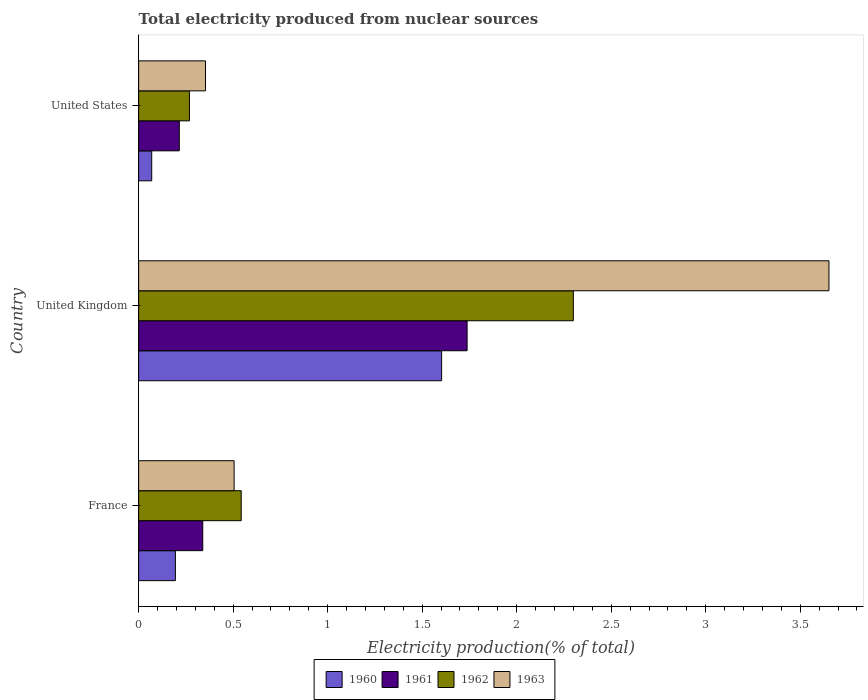How many different coloured bars are there?
Your response must be concise. 4. Are the number of bars per tick equal to the number of legend labels?
Offer a terse response. Yes. How many bars are there on the 1st tick from the bottom?
Give a very brief answer. 4. What is the total electricity produced in 1963 in United States?
Keep it short and to the point. 0.35. Across all countries, what is the maximum total electricity produced in 1963?
Offer a terse response. 3.65. Across all countries, what is the minimum total electricity produced in 1960?
Offer a terse response. 0.07. In which country was the total electricity produced in 1961 minimum?
Your response must be concise. United States. What is the total total electricity produced in 1961 in the graph?
Keep it short and to the point. 2.29. What is the difference between the total electricity produced in 1962 in France and that in United Kingdom?
Give a very brief answer. -1.76. What is the difference between the total electricity produced in 1961 in United States and the total electricity produced in 1963 in United Kingdom?
Give a very brief answer. -3.44. What is the average total electricity produced in 1963 per country?
Provide a short and direct response. 1.5. What is the difference between the total electricity produced in 1963 and total electricity produced in 1960 in France?
Keep it short and to the point. 0.31. In how many countries, is the total electricity produced in 1963 greater than 3.6 %?
Ensure brevity in your answer.  1. What is the ratio of the total electricity produced in 1960 in United Kingdom to that in United States?
Your answer should be compact. 23.14. Is the total electricity produced in 1962 in France less than that in United States?
Provide a short and direct response. No. Is the difference between the total electricity produced in 1963 in United Kingdom and United States greater than the difference between the total electricity produced in 1960 in United Kingdom and United States?
Your response must be concise. Yes. What is the difference between the highest and the second highest total electricity produced in 1961?
Your response must be concise. 1.4. What is the difference between the highest and the lowest total electricity produced in 1963?
Your answer should be very brief. 3.3. Is it the case that in every country, the sum of the total electricity produced in 1962 and total electricity produced in 1960 is greater than the sum of total electricity produced in 1963 and total electricity produced in 1961?
Keep it short and to the point. No. Is it the case that in every country, the sum of the total electricity produced in 1963 and total electricity produced in 1961 is greater than the total electricity produced in 1962?
Offer a terse response. Yes. Are all the bars in the graph horizontal?
Provide a succinct answer. Yes. How many countries are there in the graph?
Your response must be concise. 3. Are the values on the major ticks of X-axis written in scientific E-notation?
Offer a very short reply. No. Does the graph contain any zero values?
Offer a terse response. No. How many legend labels are there?
Make the answer very short. 4. What is the title of the graph?
Provide a succinct answer. Total electricity produced from nuclear sources. Does "1982" appear as one of the legend labels in the graph?
Provide a succinct answer. No. What is the Electricity production(% of total) in 1960 in France?
Your response must be concise. 0.19. What is the Electricity production(% of total) in 1961 in France?
Make the answer very short. 0.34. What is the Electricity production(% of total) of 1962 in France?
Your answer should be compact. 0.54. What is the Electricity production(% of total) in 1963 in France?
Ensure brevity in your answer.  0.51. What is the Electricity production(% of total) of 1960 in United Kingdom?
Keep it short and to the point. 1.6. What is the Electricity production(% of total) in 1961 in United Kingdom?
Your answer should be compact. 1.74. What is the Electricity production(% of total) of 1962 in United Kingdom?
Give a very brief answer. 2.3. What is the Electricity production(% of total) of 1963 in United Kingdom?
Your answer should be compact. 3.65. What is the Electricity production(% of total) in 1960 in United States?
Provide a short and direct response. 0.07. What is the Electricity production(% of total) of 1961 in United States?
Provide a short and direct response. 0.22. What is the Electricity production(% of total) of 1962 in United States?
Provide a succinct answer. 0.27. What is the Electricity production(% of total) of 1963 in United States?
Offer a terse response. 0.35. Across all countries, what is the maximum Electricity production(% of total) in 1960?
Your answer should be very brief. 1.6. Across all countries, what is the maximum Electricity production(% of total) in 1961?
Keep it short and to the point. 1.74. Across all countries, what is the maximum Electricity production(% of total) of 1962?
Your response must be concise. 2.3. Across all countries, what is the maximum Electricity production(% of total) of 1963?
Offer a very short reply. 3.65. Across all countries, what is the minimum Electricity production(% of total) in 1960?
Give a very brief answer. 0.07. Across all countries, what is the minimum Electricity production(% of total) of 1961?
Your answer should be very brief. 0.22. Across all countries, what is the minimum Electricity production(% of total) in 1962?
Make the answer very short. 0.27. Across all countries, what is the minimum Electricity production(% of total) of 1963?
Keep it short and to the point. 0.35. What is the total Electricity production(% of total) of 1960 in the graph?
Keep it short and to the point. 1.87. What is the total Electricity production(% of total) of 1961 in the graph?
Offer a very short reply. 2.29. What is the total Electricity production(% of total) in 1962 in the graph?
Offer a very short reply. 3.11. What is the total Electricity production(% of total) in 1963 in the graph?
Make the answer very short. 4.51. What is the difference between the Electricity production(% of total) in 1960 in France and that in United Kingdom?
Give a very brief answer. -1.41. What is the difference between the Electricity production(% of total) in 1961 in France and that in United Kingdom?
Provide a short and direct response. -1.4. What is the difference between the Electricity production(% of total) of 1962 in France and that in United Kingdom?
Ensure brevity in your answer.  -1.76. What is the difference between the Electricity production(% of total) of 1963 in France and that in United Kingdom?
Offer a terse response. -3.15. What is the difference between the Electricity production(% of total) in 1960 in France and that in United States?
Your answer should be compact. 0.13. What is the difference between the Electricity production(% of total) in 1961 in France and that in United States?
Provide a succinct answer. 0.12. What is the difference between the Electricity production(% of total) in 1962 in France and that in United States?
Provide a short and direct response. 0.27. What is the difference between the Electricity production(% of total) in 1963 in France and that in United States?
Your response must be concise. 0.15. What is the difference between the Electricity production(% of total) in 1960 in United Kingdom and that in United States?
Offer a very short reply. 1.53. What is the difference between the Electricity production(% of total) of 1961 in United Kingdom and that in United States?
Give a very brief answer. 1.52. What is the difference between the Electricity production(% of total) of 1962 in United Kingdom and that in United States?
Offer a terse response. 2.03. What is the difference between the Electricity production(% of total) in 1963 in United Kingdom and that in United States?
Offer a terse response. 3.3. What is the difference between the Electricity production(% of total) of 1960 in France and the Electricity production(% of total) of 1961 in United Kingdom?
Provide a short and direct response. -1.54. What is the difference between the Electricity production(% of total) of 1960 in France and the Electricity production(% of total) of 1962 in United Kingdom?
Your answer should be very brief. -2.11. What is the difference between the Electricity production(% of total) of 1960 in France and the Electricity production(% of total) of 1963 in United Kingdom?
Keep it short and to the point. -3.46. What is the difference between the Electricity production(% of total) in 1961 in France and the Electricity production(% of total) in 1962 in United Kingdom?
Keep it short and to the point. -1.96. What is the difference between the Electricity production(% of total) of 1961 in France and the Electricity production(% of total) of 1963 in United Kingdom?
Ensure brevity in your answer.  -3.31. What is the difference between the Electricity production(% of total) of 1962 in France and the Electricity production(% of total) of 1963 in United Kingdom?
Provide a short and direct response. -3.11. What is the difference between the Electricity production(% of total) in 1960 in France and the Electricity production(% of total) in 1961 in United States?
Keep it short and to the point. -0.02. What is the difference between the Electricity production(% of total) of 1960 in France and the Electricity production(% of total) of 1962 in United States?
Provide a succinct answer. -0.07. What is the difference between the Electricity production(% of total) in 1960 in France and the Electricity production(% of total) in 1963 in United States?
Offer a terse response. -0.16. What is the difference between the Electricity production(% of total) in 1961 in France and the Electricity production(% of total) in 1962 in United States?
Keep it short and to the point. 0.07. What is the difference between the Electricity production(% of total) of 1961 in France and the Electricity production(% of total) of 1963 in United States?
Offer a very short reply. -0.01. What is the difference between the Electricity production(% of total) of 1962 in France and the Electricity production(% of total) of 1963 in United States?
Keep it short and to the point. 0.19. What is the difference between the Electricity production(% of total) in 1960 in United Kingdom and the Electricity production(% of total) in 1961 in United States?
Offer a terse response. 1.39. What is the difference between the Electricity production(% of total) in 1960 in United Kingdom and the Electricity production(% of total) in 1962 in United States?
Give a very brief answer. 1.33. What is the difference between the Electricity production(% of total) of 1960 in United Kingdom and the Electricity production(% of total) of 1963 in United States?
Ensure brevity in your answer.  1.25. What is the difference between the Electricity production(% of total) in 1961 in United Kingdom and the Electricity production(% of total) in 1962 in United States?
Ensure brevity in your answer.  1.47. What is the difference between the Electricity production(% of total) of 1961 in United Kingdom and the Electricity production(% of total) of 1963 in United States?
Your answer should be compact. 1.38. What is the difference between the Electricity production(% of total) in 1962 in United Kingdom and the Electricity production(% of total) in 1963 in United States?
Provide a short and direct response. 1.95. What is the average Electricity production(% of total) of 1960 per country?
Provide a succinct answer. 0.62. What is the average Electricity production(% of total) of 1961 per country?
Offer a very short reply. 0.76. What is the average Electricity production(% of total) of 1962 per country?
Provide a short and direct response. 1.04. What is the average Electricity production(% of total) in 1963 per country?
Give a very brief answer. 1.5. What is the difference between the Electricity production(% of total) in 1960 and Electricity production(% of total) in 1961 in France?
Your response must be concise. -0.14. What is the difference between the Electricity production(% of total) of 1960 and Electricity production(% of total) of 1962 in France?
Provide a succinct answer. -0.35. What is the difference between the Electricity production(% of total) of 1960 and Electricity production(% of total) of 1963 in France?
Provide a short and direct response. -0.31. What is the difference between the Electricity production(% of total) of 1961 and Electricity production(% of total) of 1962 in France?
Provide a succinct answer. -0.2. What is the difference between the Electricity production(% of total) in 1961 and Electricity production(% of total) in 1963 in France?
Give a very brief answer. -0.17. What is the difference between the Electricity production(% of total) in 1962 and Electricity production(% of total) in 1963 in France?
Keep it short and to the point. 0.04. What is the difference between the Electricity production(% of total) of 1960 and Electricity production(% of total) of 1961 in United Kingdom?
Ensure brevity in your answer.  -0.13. What is the difference between the Electricity production(% of total) in 1960 and Electricity production(% of total) in 1962 in United Kingdom?
Your answer should be compact. -0.7. What is the difference between the Electricity production(% of total) in 1960 and Electricity production(% of total) in 1963 in United Kingdom?
Keep it short and to the point. -2.05. What is the difference between the Electricity production(% of total) in 1961 and Electricity production(% of total) in 1962 in United Kingdom?
Offer a very short reply. -0.56. What is the difference between the Electricity production(% of total) in 1961 and Electricity production(% of total) in 1963 in United Kingdom?
Offer a very short reply. -1.91. What is the difference between the Electricity production(% of total) in 1962 and Electricity production(% of total) in 1963 in United Kingdom?
Ensure brevity in your answer.  -1.35. What is the difference between the Electricity production(% of total) of 1960 and Electricity production(% of total) of 1961 in United States?
Give a very brief answer. -0.15. What is the difference between the Electricity production(% of total) in 1960 and Electricity production(% of total) in 1962 in United States?
Keep it short and to the point. -0.2. What is the difference between the Electricity production(% of total) in 1960 and Electricity production(% of total) in 1963 in United States?
Your answer should be compact. -0.28. What is the difference between the Electricity production(% of total) of 1961 and Electricity production(% of total) of 1962 in United States?
Offer a terse response. -0.05. What is the difference between the Electricity production(% of total) of 1961 and Electricity production(% of total) of 1963 in United States?
Your answer should be compact. -0.14. What is the difference between the Electricity production(% of total) in 1962 and Electricity production(% of total) in 1963 in United States?
Your answer should be very brief. -0.09. What is the ratio of the Electricity production(% of total) of 1960 in France to that in United Kingdom?
Your answer should be compact. 0.12. What is the ratio of the Electricity production(% of total) of 1961 in France to that in United Kingdom?
Your answer should be very brief. 0.2. What is the ratio of the Electricity production(% of total) of 1962 in France to that in United Kingdom?
Provide a succinct answer. 0.24. What is the ratio of the Electricity production(% of total) in 1963 in France to that in United Kingdom?
Offer a very short reply. 0.14. What is the ratio of the Electricity production(% of total) of 1960 in France to that in United States?
Give a very brief answer. 2.81. What is the ratio of the Electricity production(% of total) of 1961 in France to that in United States?
Offer a terse response. 1.58. What is the ratio of the Electricity production(% of total) of 1962 in France to that in United States?
Your answer should be compact. 2.02. What is the ratio of the Electricity production(% of total) of 1963 in France to that in United States?
Provide a short and direct response. 1.43. What is the ratio of the Electricity production(% of total) in 1960 in United Kingdom to that in United States?
Keep it short and to the point. 23.14. What is the ratio of the Electricity production(% of total) of 1961 in United Kingdom to that in United States?
Your answer should be very brief. 8.08. What is the ratio of the Electricity production(% of total) in 1962 in United Kingdom to that in United States?
Give a very brief answer. 8.56. What is the ratio of the Electricity production(% of total) in 1963 in United Kingdom to that in United States?
Your response must be concise. 10.32. What is the difference between the highest and the second highest Electricity production(% of total) of 1960?
Your answer should be compact. 1.41. What is the difference between the highest and the second highest Electricity production(% of total) of 1961?
Your response must be concise. 1.4. What is the difference between the highest and the second highest Electricity production(% of total) of 1962?
Make the answer very short. 1.76. What is the difference between the highest and the second highest Electricity production(% of total) of 1963?
Offer a terse response. 3.15. What is the difference between the highest and the lowest Electricity production(% of total) of 1960?
Your answer should be very brief. 1.53. What is the difference between the highest and the lowest Electricity production(% of total) in 1961?
Ensure brevity in your answer.  1.52. What is the difference between the highest and the lowest Electricity production(% of total) of 1962?
Your answer should be compact. 2.03. What is the difference between the highest and the lowest Electricity production(% of total) of 1963?
Your answer should be very brief. 3.3. 